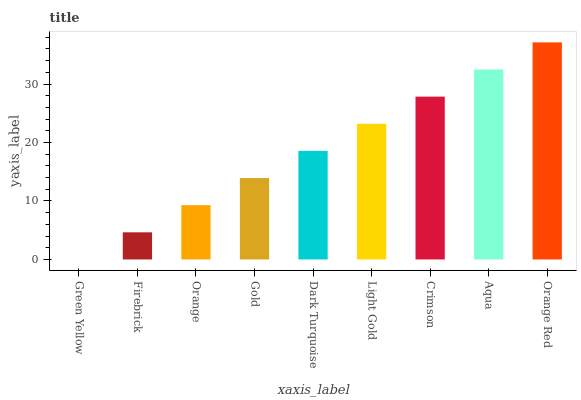Is Green Yellow the minimum?
Answer yes or no. Yes. Is Orange Red the maximum?
Answer yes or no. Yes. Is Firebrick the minimum?
Answer yes or no. No. Is Firebrick the maximum?
Answer yes or no. No. Is Firebrick greater than Green Yellow?
Answer yes or no. Yes. Is Green Yellow less than Firebrick?
Answer yes or no. Yes. Is Green Yellow greater than Firebrick?
Answer yes or no. No. Is Firebrick less than Green Yellow?
Answer yes or no. No. Is Dark Turquoise the high median?
Answer yes or no. Yes. Is Dark Turquoise the low median?
Answer yes or no. Yes. Is Firebrick the high median?
Answer yes or no. No. Is Aqua the low median?
Answer yes or no. No. 